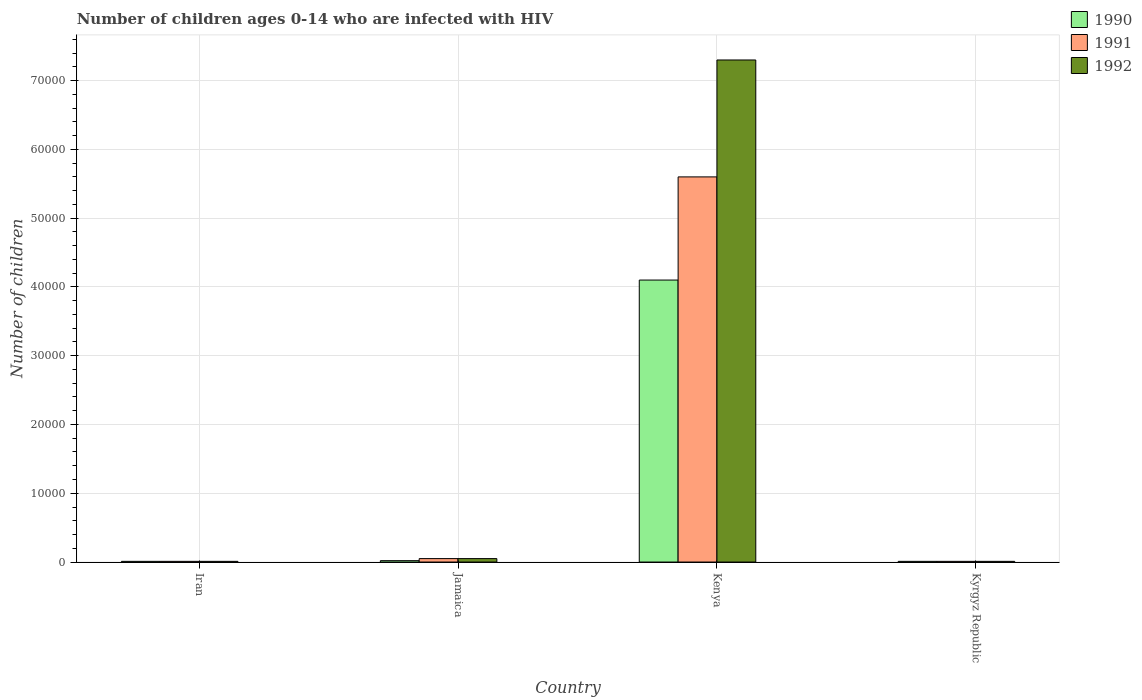Are the number of bars per tick equal to the number of legend labels?
Give a very brief answer. Yes. How many bars are there on the 4th tick from the left?
Offer a terse response. 3. What is the label of the 1st group of bars from the left?
Offer a terse response. Iran. In how many cases, is the number of bars for a given country not equal to the number of legend labels?
Keep it short and to the point. 0. What is the number of HIV infected children in 1990 in Jamaica?
Give a very brief answer. 200. Across all countries, what is the maximum number of HIV infected children in 1990?
Give a very brief answer. 4.10e+04. Across all countries, what is the minimum number of HIV infected children in 1991?
Keep it short and to the point. 100. In which country was the number of HIV infected children in 1991 maximum?
Make the answer very short. Kenya. In which country was the number of HIV infected children in 1992 minimum?
Keep it short and to the point. Iran. What is the total number of HIV infected children in 1992 in the graph?
Make the answer very short. 7.37e+04. What is the difference between the number of HIV infected children in 1992 in Iran and that in Kenya?
Ensure brevity in your answer.  -7.29e+04. What is the difference between the number of HIV infected children in 1991 in Kyrgyz Republic and the number of HIV infected children in 1990 in Kenya?
Make the answer very short. -4.09e+04. What is the average number of HIV infected children in 1991 per country?
Ensure brevity in your answer.  1.42e+04. What is the difference between the number of HIV infected children of/in 1992 and number of HIV infected children of/in 1991 in Kenya?
Give a very brief answer. 1.70e+04. Is the difference between the number of HIV infected children in 1992 in Iran and Kenya greater than the difference between the number of HIV infected children in 1991 in Iran and Kenya?
Your answer should be very brief. No. What is the difference between the highest and the second highest number of HIV infected children in 1990?
Ensure brevity in your answer.  4.09e+04. What is the difference between the highest and the lowest number of HIV infected children in 1990?
Your response must be concise. 4.09e+04. What does the 2nd bar from the right in Iran represents?
Your answer should be compact. 1991. How many bars are there?
Provide a succinct answer. 12. Are all the bars in the graph horizontal?
Your answer should be very brief. No. How many countries are there in the graph?
Offer a terse response. 4. Are the values on the major ticks of Y-axis written in scientific E-notation?
Make the answer very short. No. Does the graph contain any zero values?
Your answer should be very brief. No. Does the graph contain grids?
Offer a very short reply. Yes. How are the legend labels stacked?
Your answer should be compact. Vertical. What is the title of the graph?
Ensure brevity in your answer.  Number of children ages 0-14 who are infected with HIV. What is the label or title of the Y-axis?
Your answer should be compact. Number of children. What is the Number of children of 1991 in Iran?
Keep it short and to the point. 100. What is the Number of children of 1990 in Jamaica?
Ensure brevity in your answer.  200. What is the Number of children in 1992 in Jamaica?
Provide a short and direct response. 500. What is the Number of children in 1990 in Kenya?
Keep it short and to the point. 4.10e+04. What is the Number of children in 1991 in Kenya?
Provide a succinct answer. 5.60e+04. What is the Number of children in 1992 in Kenya?
Ensure brevity in your answer.  7.30e+04. What is the Number of children of 1990 in Kyrgyz Republic?
Offer a very short reply. 100. What is the Number of children in 1991 in Kyrgyz Republic?
Make the answer very short. 100. Across all countries, what is the maximum Number of children in 1990?
Provide a short and direct response. 4.10e+04. Across all countries, what is the maximum Number of children in 1991?
Make the answer very short. 5.60e+04. Across all countries, what is the maximum Number of children of 1992?
Your answer should be compact. 7.30e+04. Across all countries, what is the minimum Number of children in 1991?
Make the answer very short. 100. What is the total Number of children in 1990 in the graph?
Give a very brief answer. 4.14e+04. What is the total Number of children of 1991 in the graph?
Offer a terse response. 5.67e+04. What is the total Number of children of 1992 in the graph?
Your response must be concise. 7.37e+04. What is the difference between the Number of children in 1990 in Iran and that in Jamaica?
Your answer should be very brief. -100. What is the difference between the Number of children of 1991 in Iran and that in Jamaica?
Your response must be concise. -400. What is the difference between the Number of children in 1992 in Iran and that in Jamaica?
Your answer should be compact. -400. What is the difference between the Number of children of 1990 in Iran and that in Kenya?
Make the answer very short. -4.09e+04. What is the difference between the Number of children of 1991 in Iran and that in Kenya?
Provide a succinct answer. -5.59e+04. What is the difference between the Number of children in 1992 in Iran and that in Kenya?
Make the answer very short. -7.29e+04. What is the difference between the Number of children in 1990 in Iran and that in Kyrgyz Republic?
Your response must be concise. 0. What is the difference between the Number of children of 1992 in Iran and that in Kyrgyz Republic?
Make the answer very short. 0. What is the difference between the Number of children in 1990 in Jamaica and that in Kenya?
Ensure brevity in your answer.  -4.08e+04. What is the difference between the Number of children in 1991 in Jamaica and that in Kenya?
Your answer should be very brief. -5.55e+04. What is the difference between the Number of children in 1992 in Jamaica and that in Kenya?
Make the answer very short. -7.25e+04. What is the difference between the Number of children of 1992 in Jamaica and that in Kyrgyz Republic?
Offer a very short reply. 400. What is the difference between the Number of children in 1990 in Kenya and that in Kyrgyz Republic?
Provide a succinct answer. 4.09e+04. What is the difference between the Number of children of 1991 in Kenya and that in Kyrgyz Republic?
Your answer should be very brief. 5.59e+04. What is the difference between the Number of children of 1992 in Kenya and that in Kyrgyz Republic?
Provide a short and direct response. 7.29e+04. What is the difference between the Number of children of 1990 in Iran and the Number of children of 1991 in Jamaica?
Ensure brevity in your answer.  -400. What is the difference between the Number of children of 1990 in Iran and the Number of children of 1992 in Jamaica?
Offer a very short reply. -400. What is the difference between the Number of children in 1991 in Iran and the Number of children in 1992 in Jamaica?
Provide a succinct answer. -400. What is the difference between the Number of children in 1990 in Iran and the Number of children in 1991 in Kenya?
Give a very brief answer. -5.59e+04. What is the difference between the Number of children in 1990 in Iran and the Number of children in 1992 in Kenya?
Give a very brief answer. -7.29e+04. What is the difference between the Number of children in 1991 in Iran and the Number of children in 1992 in Kenya?
Ensure brevity in your answer.  -7.29e+04. What is the difference between the Number of children of 1990 in Jamaica and the Number of children of 1991 in Kenya?
Your answer should be compact. -5.58e+04. What is the difference between the Number of children in 1990 in Jamaica and the Number of children in 1992 in Kenya?
Provide a short and direct response. -7.28e+04. What is the difference between the Number of children in 1991 in Jamaica and the Number of children in 1992 in Kenya?
Your response must be concise. -7.25e+04. What is the difference between the Number of children in 1990 in Jamaica and the Number of children in 1991 in Kyrgyz Republic?
Keep it short and to the point. 100. What is the difference between the Number of children of 1990 in Kenya and the Number of children of 1991 in Kyrgyz Republic?
Make the answer very short. 4.09e+04. What is the difference between the Number of children of 1990 in Kenya and the Number of children of 1992 in Kyrgyz Republic?
Make the answer very short. 4.09e+04. What is the difference between the Number of children in 1991 in Kenya and the Number of children in 1992 in Kyrgyz Republic?
Provide a succinct answer. 5.59e+04. What is the average Number of children in 1990 per country?
Your answer should be very brief. 1.04e+04. What is the average Number of children of 1991 per country?
Offer a very short reply. 1.42e+04. What is the average Number of children in 1992 per country?
Make the answer very short. 1.84e+04. What is the difference between the Number of children in 1990 and Number of children in 1992 in Iran?
Your answer should be very brief. 0. What is the difference between the Number of children in 1991 and Number of children in 1992 in Iran?
Your answer should be very brief. 0. What is the difference between the Number of children in 1990 and Number of children in 1991 in Jamaica?
Offer a very short reply. -300. What is the difference between the Number of children of 1990 and Number of children of 1992 in Jamaica?
Your answer should be compact. -300. What is the difference between the Number of children of 1991 and Number of children of 1992 in Jamaica?
Provide a short and direct response. 0. What is the difference between the Number of children of 1990 and Number of children of 1991 in Kenya?
Give a very brief answer. -1.50e+04. What is the difference between the Number of children in 1990 and Number of children in 1992 in Kenya?
Your response must be concise. -3.20e+04. What is the difference between the Number of children of 1991 and Number of children of 1992 in Kenya?
Offer a very short reply. -1.70e+04. What is the difference between the Number of children of 1990 and Number of children of 1991 in Kyrgyz Republic?
Give a very brief answer. 0. What is the difference between the Number of children in 1990 and Number of children in 1992 in Kyrgyz Republic?
Give a very brief answer. 0. What is the difference between the Number of children in 1991 and Number of children in 1992 in Kyrgyz Republic?
Provide a succinct answer. 0. What is the ratio of the Number of children in 1990 in Iran to that in Jamaica?
Provide a succinct answer. 0.5. What is the ratio of the Number of children in 1991 in Iran to that in Jamaica?
Ensure brevity in your answer.  0.2. What is the ratio of the Number of children of 1992 in Iran to that in Jamaica?
Your answer should be very brief. 0.2. What is the ratio of the Number of children of 1990 in Iran to that in Kenya?
Provide a short and direct response. 0. What is the ratio of the Number of children in 1991 in Iran to that in Kenya?
Your response must be concise. 0. What is the ratio of the Number of children in 1992 in Iran to that in Kenya?
Offer a very short reply. 0. What is the ratio of the Number of children of 1991 in Iran to that in Kyrgyz Republic?
Offer a very short reply. 1. What is the ratio of the Number of children of 1992 in Iran to that in Kyrgyz Republic?
Your answer should be compact. 1. What is the ratio of the Number of children of 1990 in Jamaica to that in Kenya?
Provide a succinct answer. 0. What is the ratio of the Number of children in 1991 in Jamaica to that in Kenya?
Your answer should be compact. 0.01. What is the ratio of the Number of children of 1992 in Jamaica to that in Kenya?
Offer a very short reply. 0.01. What is the ratio of the Number of children of 1990 in Jamaica to that in Kyrgyz Republic?
Your answer should be compact. 2. What is the ratio of the Number of children in 1990 in Kenya to that in Kyrgyz Republic?
Make the answer very short. 410. What is the ratio of the Number of children of 1991 in Kenya to that in Kyrgyz Republic?
Make the answer very short. 560. What is the ratio of the Number of children of 1992 in Kenya to that in Kyrgyz Republic?
Your answer should be compact. 730. What is the difference between the highest and the second highest Number of children of 1990?
Your answer should be compact. 4.08e+04. What is the difference between the highest and the second highest Number of children of 1991?
Ensure brevity in your answer.  5.55e+04. What is the difference between the highest and the second highest Number of children of 1992?
Make the answer very short. 7.25e+04. What is the difference between the highest and the lowest Number of children in 1990?
Offer a terse response. 4.09e+04. What is the difference between the highest and the lowest Number of children in 1991?
Provide a succinct answer. 5.59e+04. What is the difference between the highest and the lowest Number of children of 1992?
Your response must be concise. 7.29e+04. 